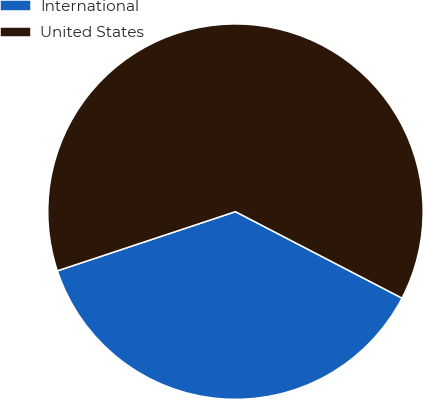Convert chart to OTSL. <chart><loc_0><loc_0><loc_500><loc_500><pie_chart><fcel>International<fcel>United States<nl><fcel>37.27%<fcel>62.73%<nl></chart> 